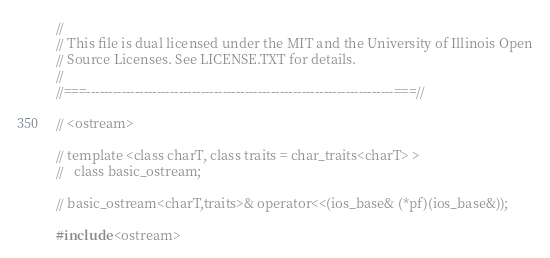<code> <loc_0><loc_0><loc_500><loc_500><_C++_>//
// This file is dual licensed under the MIT and the University of Illinois Open
// Source Licenses. See LICENSE.TXT for details.
//
//===----------------------------------------------------------------------===//

// <ostream>

// template <class charT, class traits = char_traits<charT> >
//   class basic_ostream;

// basic_ostream<charT,traits>& operator<<(ios_base& (*pf)(ios_base&));

#include <ostream></code> 